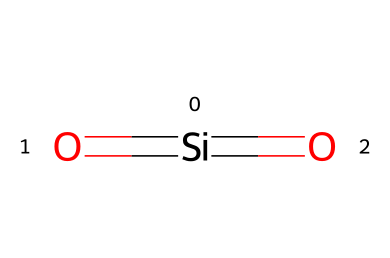What is the total number of oxygen atoms in this structure? The chemical structure shows two oxygen atoms that are connected to silicon, as indicated by the two double bonds.
Answer: 2 What is the primary element in this chemical? The structure consists of silicon and oxygen, but silicon is the central atom in this representation, making it the primary element.
Answer: silicon How many double bonds are present in this structure? There are two double bonds in this structure, one connecting each oxygen atom to the silicon atom.
Answer: 2 What is the role of silicon dioxide in ceramics? Silicon dioxide provides durability and thermal stability in ceramic materials, often serving as a primary component to enhance the mechanical properties of ceramics.
Answer: durability Can this chemical structure be classified as a ceramic? This structure is representative of silicon dioxide, which is indeed classified as a ceramic material due to its crystalline structure and high melting point, making it suitable for electronic applications.
Answer: yes How does the presence of silicon affect the thermal properties of ceramic coatings? The presence of silicon in the silicon dioxide structure contributes to high thermal stability and low thermal conductivity, important for electronic applications, ensuring efficient heat distribution and resistance to thermal shock.
Answer: high thermal stability 